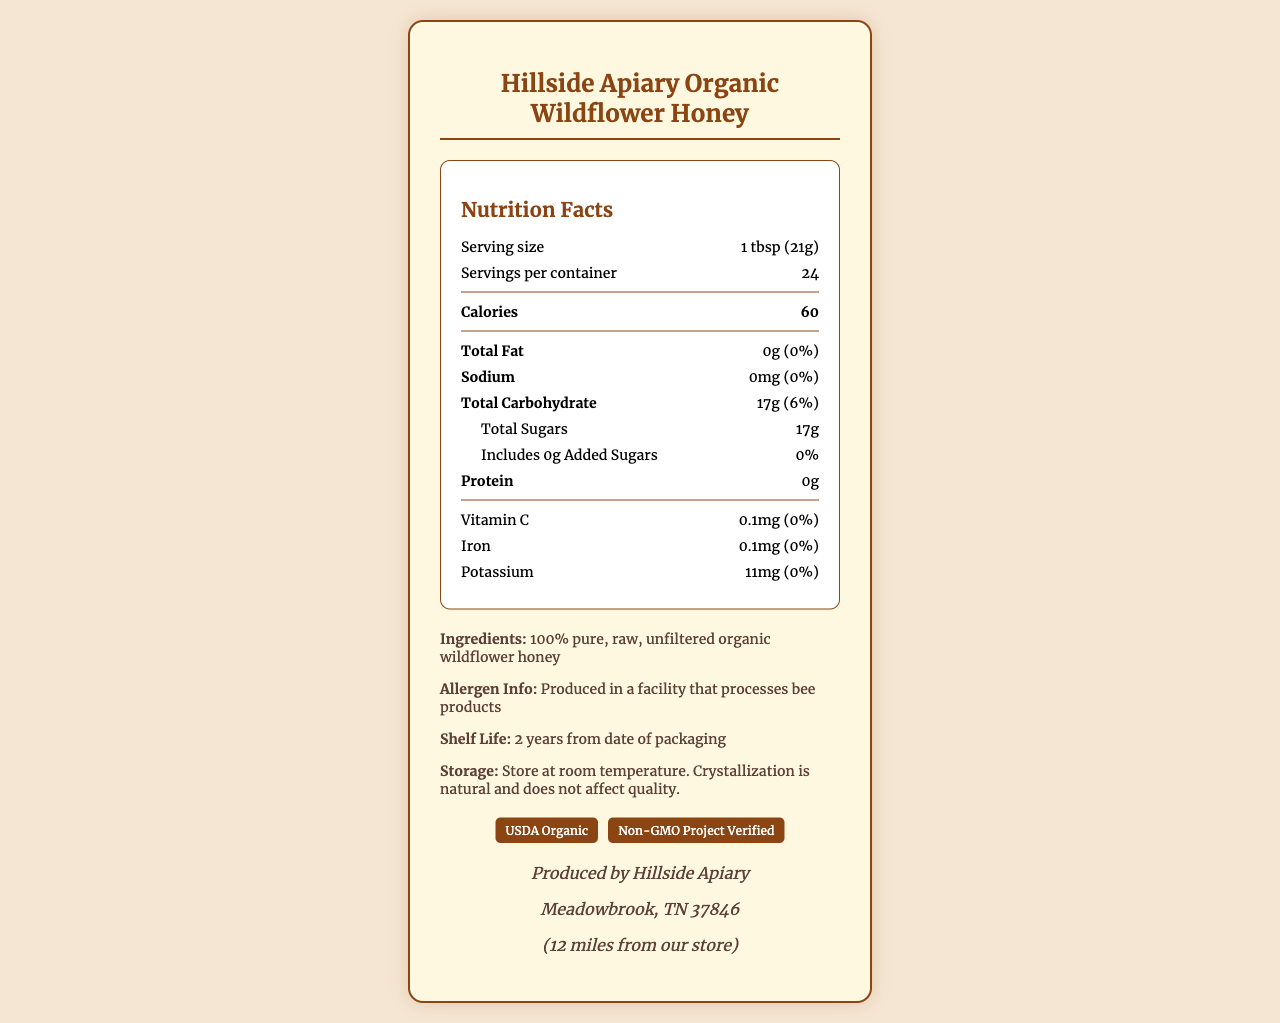what is the serving size? The serving size is listed at the top of the nutrition facts section on the document.
Answer: 1 tbsp (21g) how many calories are in one serving? The calories per serving are clearly stated in the bold section of the nutrition facts.
Answer: 60 what is the total carbohydrate amount per serving? The amount of total carbohydrate is mentioned under the carbohydrate section.
Answer: 17g how much iron is in one serving? The iron content per serving is listed in the vitamins and minerals section.
Answer: 0.1mg what are the ingredients? The ingredients are specified in the additional information section.
Answer: 100% pure, raw, unfiltered organic wildflower honey what certification does the product have? A. Gluten-Free B. USDA Organic C. Fair Trade Certified The document lists "USDA Organic" and "Non-GMO Project Verified" as certifications.
Answer: B how many servings are there per container? A. 10 B. 24 C. 30 D. 50 The document specifies that there are 24 servings per container.
Answer: B is there any added sugar in this honey? The total sugars section states 0g of added sugars.
Answer: No was the honey produced in Meadowbrook, TN? The producer information confirms that Hillside Apiary is located in Meadowbrook, TN.
Answer: Yes what does the allergen information state? The allergen information is included in the additional info section.
Answer: Produced in a facility that processes bee products how many certifications are listed for this product? The document shows "USDA Organic" and "Non-GMO Project Verified" certifications.
Answer: 2 what is the shelf life of the honey? The shelf life information is mentioned in the additional info section.
Answer: 2 years from date of packaging where should this honey be placed in the bookstore? The display suggestion in the document advises placing it near the nature and gardening books section.
Answer: Near the nature and gardening books section what is the specific daily value percentage of sodium per serving? The sodium section in the nutrition facts shows 0% daily value.
Answer: 0% describe the additional benefits of this honey. The health benefits section lists these three benefits.
Answer: Rich in antioxidants, Natural energy source, Supports local pollinators what is the total fat content per serving? The total fat content is listed as 0g in the nutrition facts section.
Answer: 0g is this product GMO? The product is certified "Non-GMO Project Verified," indicating it is non-GMO.
Answer: No what is the storage instruction for this honey? The storage instructions are clearly listed in the additional info section.
Answer: Store at room temperature. Crystallization is natural and does not affect quality. from which apiary is this honey produced? The producer information section lists Hillside Apiary as the producer.
Answer: Hillside Apiary how far is the producer's location from the store? The distance from the store is mentioned in the producer info section.
Answer: 12 miles what health benefits does this honey offer? The health benefits are listed in the document.
Answer: Rich in antioxidants, Natural energy source, Supports local pollinators summarize the main idea of the document. The document is focused on giving a comprehensive overview of the nutritional values, benefits, and origin of the honey.
Answer: The document provides detailed nutritional information, certifications, health benefits, and producer details of Hillside Apiary Organic Wildflower Honey. The product is locally sourced, pure, and certified organic, contributing to local pollinators and sustainable agriculture. what is the vitamin A content per serving? The document does not provide any details about the vitamin A content.
Answer: Not enough information 